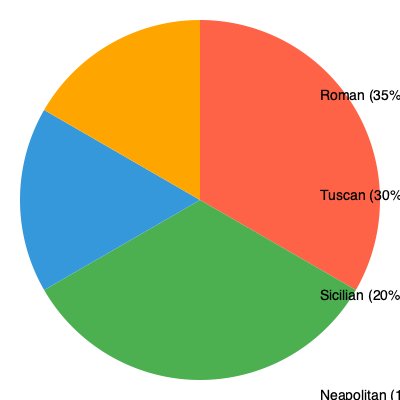Based on the pie chart showing the popularity of different Italian cuisines in Dublin restaurants, what is the ratio of the combined popularity of Roman and Tuscan cuisines to that of Sicilian and Neapolitan cuisines? To solve this problem, we need to follow these steps:

1. Identify the percentages for each cuisine:
   - Roman: 35%
   - Tuscan: 30%
   - Sicilian: 20%
   - Neapolitan: 15%

2. Calculate the combined popularity of Roman and Tuscan cuisines:
   $35\% + 30\% = 65\%$

3. Calculate the combined popularity of Sicilian and Neapolitan cuisines:
   $20\% + 15\% = 35\%$

4. Express the ratio of the combined popularities:
   $65\% : 35\%$

5. Simplify the ratio by dividing both numbers by their greatest common divisor (5):
   $\frac{65}{5} : \frac{35}{5} = 13 : 7$

Therefore, the ratio of the combined popularity of Roman and Tuscan cuisines to that of Sicilian and Neapolitan cuisines is 13:7.
Answer: 13:7 